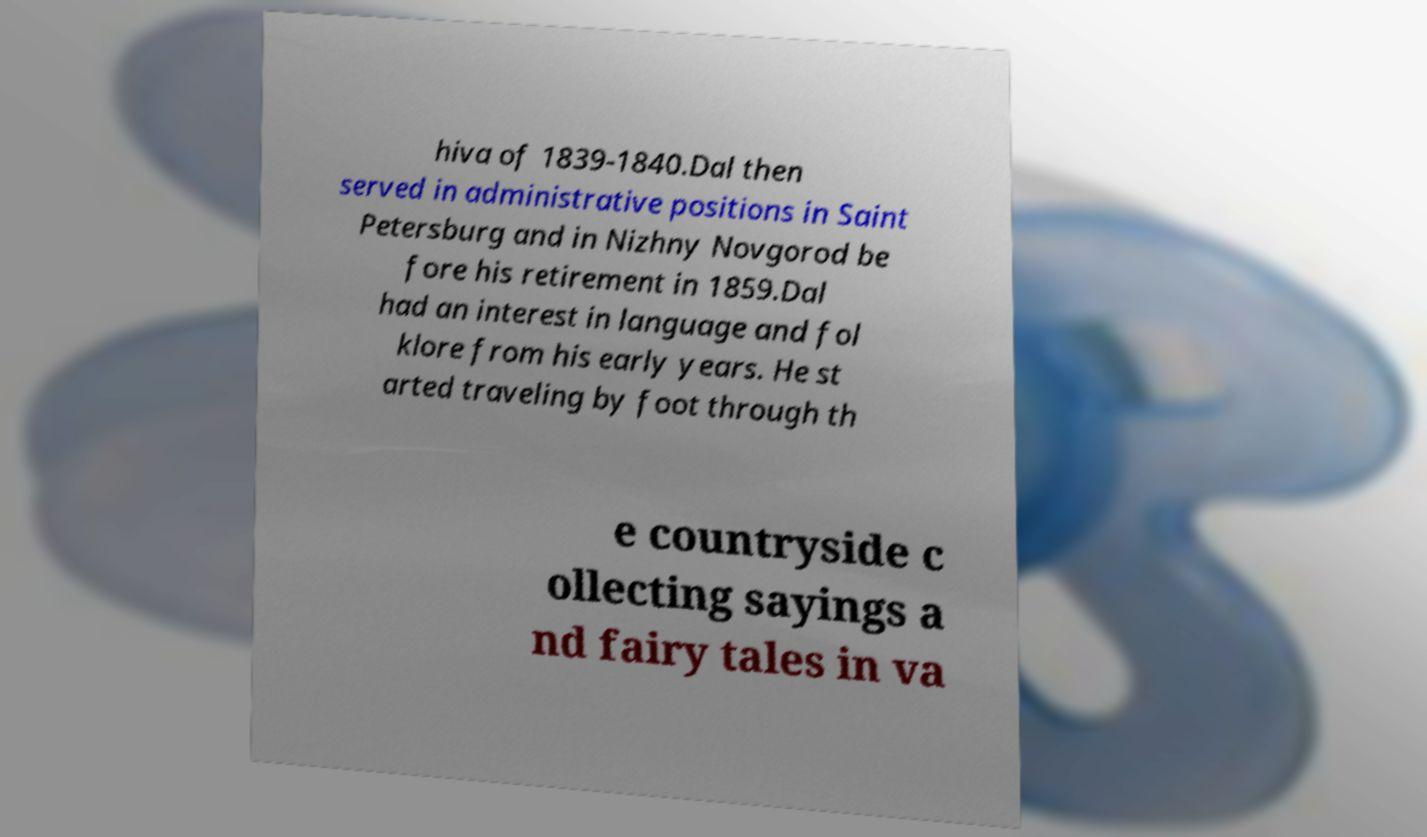Could you extract and type out the text from this image? hiva of 1839-1840.Dal then served in administrative positions in Saint Petersburg and in Nizhny Novgorod be fore his retirement in 1859.Dal had an interest in language and fol klore from his early years. He st arted traveling by foot through th e countryside c ollecting sayings a nd fairy tales in va 